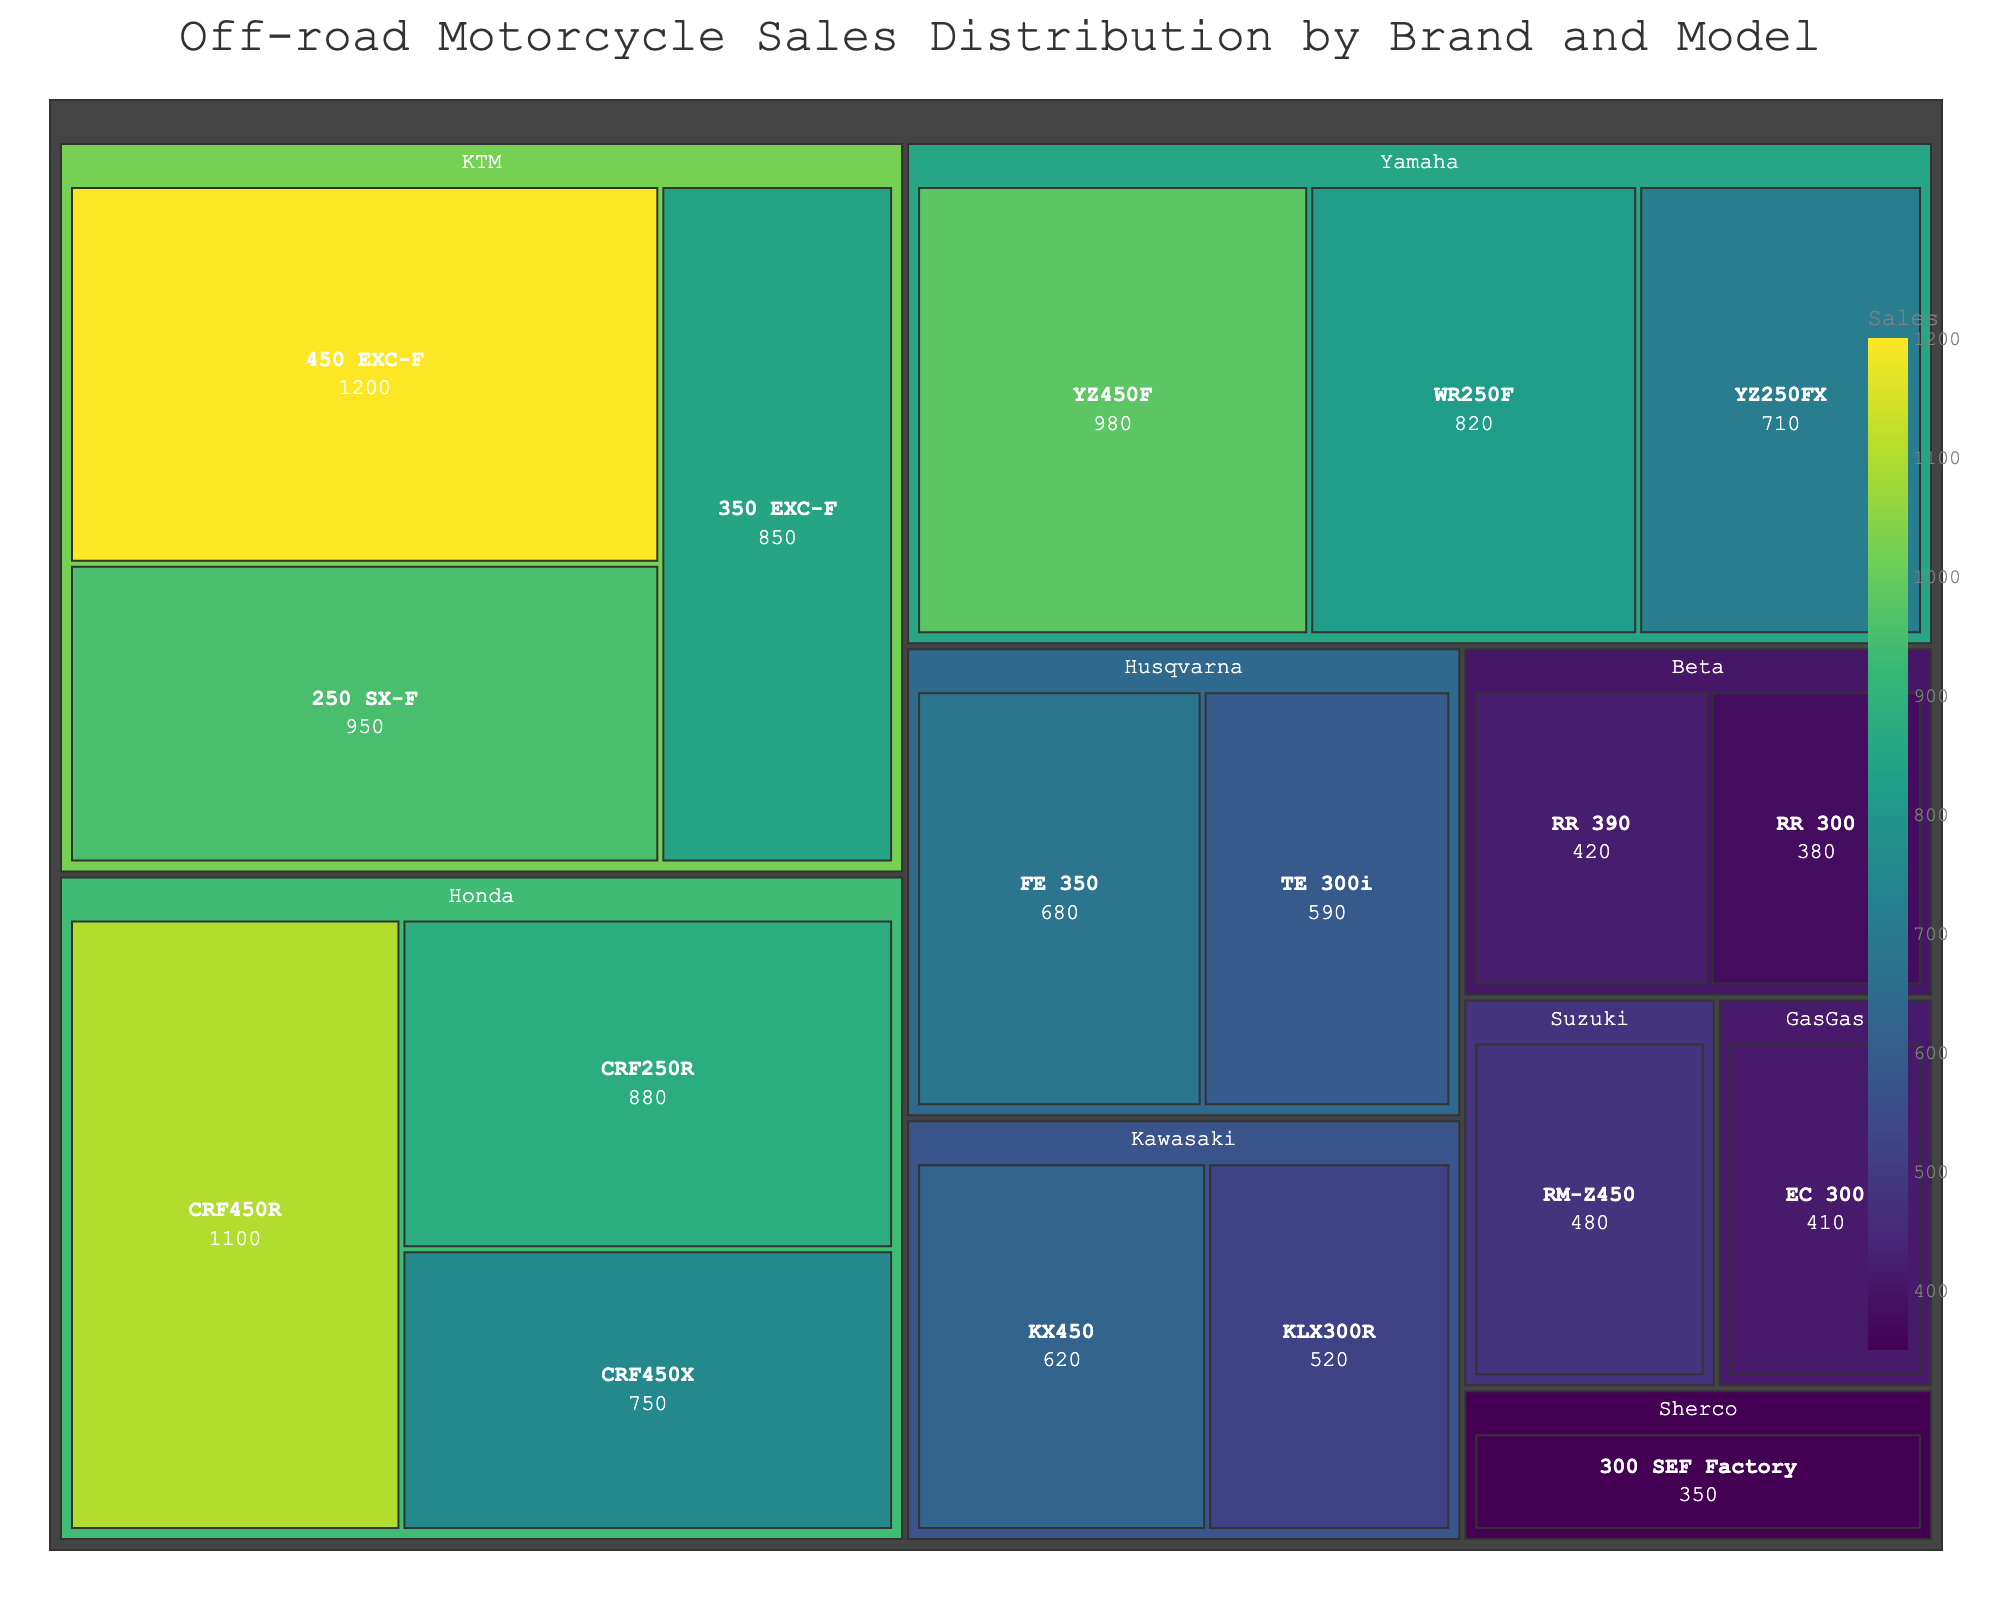Which brand has the highest overall sales? Look for the brand with the largest combined area in the treemap. KTM has the largest sections for its models, indicating the highest sales.
Answer: KTM What is the title of the treemap? The title is located at the top of the treemap, providing context for the data shown.
Answer: Off-road Motorcycle Sales Distribution by Brand and Model Which model has the highest sales? Find the model with the largest area within its brand section. KTM 450 EXC-F has the largest area.
Answer: KTM 450 EXC-F How many models does Yamaha have in the treemap? Count the individual sections within the Yamaha brand area. Yamaha has three models displayed.
Answer: 3 What is the total sales for Honda models? Sum the sales figures for all Honda models: 1100 (CRF450R) + 880 (CRF250R) + 750 (CRF450X).
Answer: 2730 Which model has higher sales: Yamaha YZ450F or Yamaha YZ250FX? Compare the sales figures for these two models: YZ450F (980) versus YZ250FX (710).
Answer: Yamaha YZ450F What is the color associated with the KTM 250 SX-F model? Observe the color gradient used in the treemap; the shade reflects the sales volume. KTM 250 SX-F has a greenish color, indicating middling-to-high sales in comparison.
Answer: greenish Which brand has the least number of models? Identify the brand with the fewest individual sections. Sherco appears to have only one model.
Answer: Sherco What is the average sales for Kawasaki models? Sum the sales for Kawasaki models (KX450: 620, KLX300R: 520), then divide by the number of models (2). Average sales = (620 + 520) / 2 = 570.
Answer: 570 